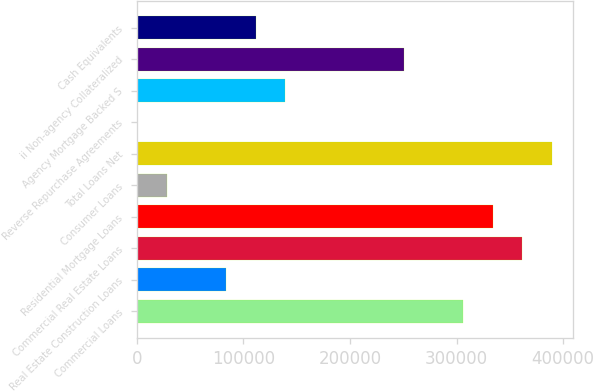<chart> <loc_0><loc_0><loc_500><loc_500><bar_chart><fcel>Commercial Loans<fcel>Real Estate Construction Loans<fcel>Commercial Real Estate Loans<fcel>Residential Mortgage Loans<fcel>Consumer Loans<fcel>Total Loans Net<fcel>Reverse Repurchase Agreements<fcel>Agency Mortgage Backed S<fcel>ii Non-agency Collateralized<fcel>Cash Equivalents<nl><fcel>306144<fcel>83600.7<fcel>361780<fcel>333962<fcel>27964.9<fcel>389598<fcel>147<fcel>139236<fcel>250508<fcel>111419<nl></chart> 